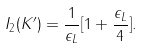Convert formula to latex. <formula><loc_0><loc_0><loc_500><loc_500>I _ { 2 } ( K ^ { \prime } ) = \frac { 1 } { \epsilon _ { L } } [ 1 + \frac { \epsilon _ { L } } { 4 } ] .</formula> 